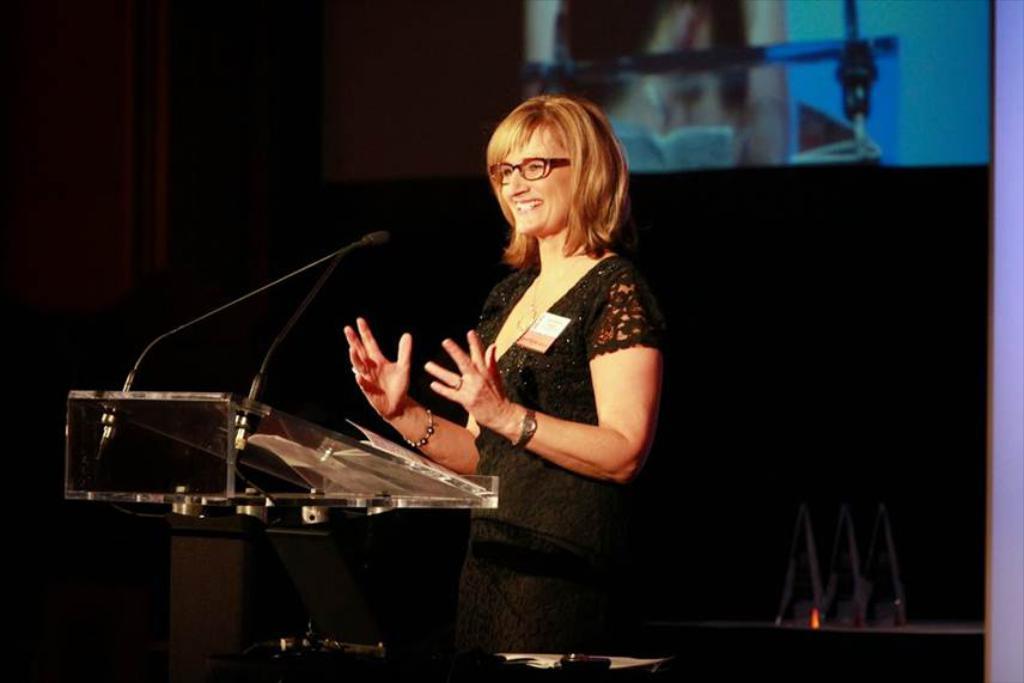Describe this image in one or two sentences. In this image in the center there is one woman who is standing and smiling, in front of her there is one podium and a mikes. In the background there is a screen and wall, and some objects. 